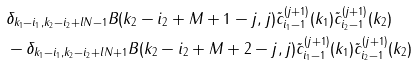Convert formula to latex. <formula><loc_0><loc_0><loc_500><loc_500>& \delta _ { k _ { 1 } - i _ { 1 } , k _ { 2 } - i _ { 2 } + l N - 1 } B ( k _ { 2 } - i _ { 2 } + M + 1 - j , j ) \tilde { c } _ { i _ { 1 } - 1 } ^ { ( j + 1 ) } ( k _ { 1 } ) \tilde { c } _ { i _ { 2 } - 1 } ^ { ( j + 1 ) } ( k _ { 2 } ) \\ & - \delta _ { k _ { 1 } - i _ { 1 } , k _ { 2 } - i _ { 2 } + l N + 1 } B ( k _ { 2 } - i _ { 2 } + M + 2 - j , j ) \tilde { c } _ { i _ { 1 } - 1 } ^ { ( j + 1 ) } ( k _ { 1 } ) \tilde { c } _ { i _ { 2 } - 1 } ^ { ( j + 1 ) } ( k _ { 2 } ) \\</formula> 